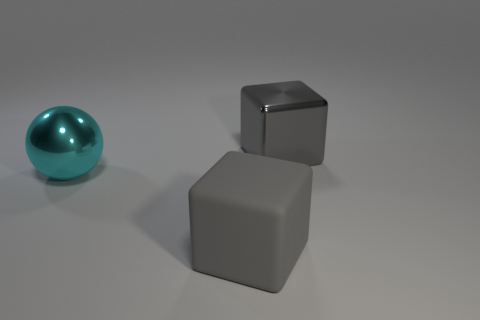Subtract all spheres. How many objects are left? 2 Add 3 brown objects. How many objects exist? 6 Subtract 1 balls. How many balls are left? 0 Subtract all big balls. Subtract all tiny red matte blocks. How many objects are left? 2 Add 3 cyan balls. How many cyan balls are left? 4 Add 2 tiny green cubes. How many tiny green cubes exist? 2 Subtract 0 blue cylinders. How many objects are left? 3 Subtract all red blocks. Subtract all gray cylinders. How many blocks are left? 2 